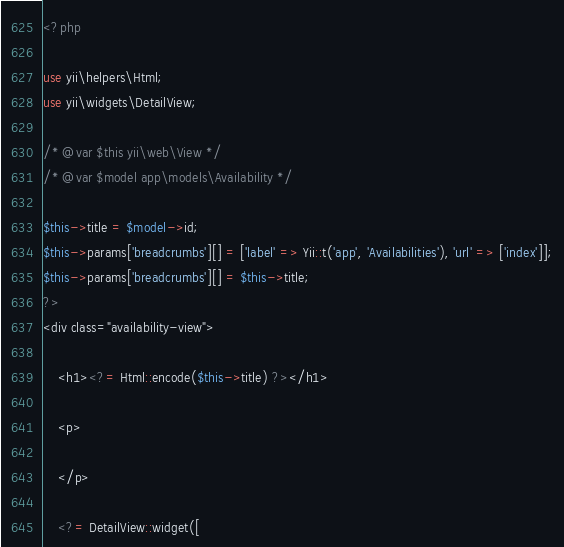Convert code to text. <code><loc_0><loc_0><loc_500><loc_500><_PHP_><?php

use yii\helpers\Html;
use yii\widgets\DetailView;

/* @var $this yii\web\View */
/* @var $model app\models\Availability */

$this->title = $model->id;
$this->params['breadcrumbs'][] = ['label' => Yii::t('app', 'Availabilities'), 'url' => ['index']];
$this->params['breadcrumbs'][] = $this->title;
?>
<div class="availability-view">

    <h1><?= Html::encode($this->title) ?></h1>

    <p>
        
    </p>

    <?= DetailView::widget([</code> 